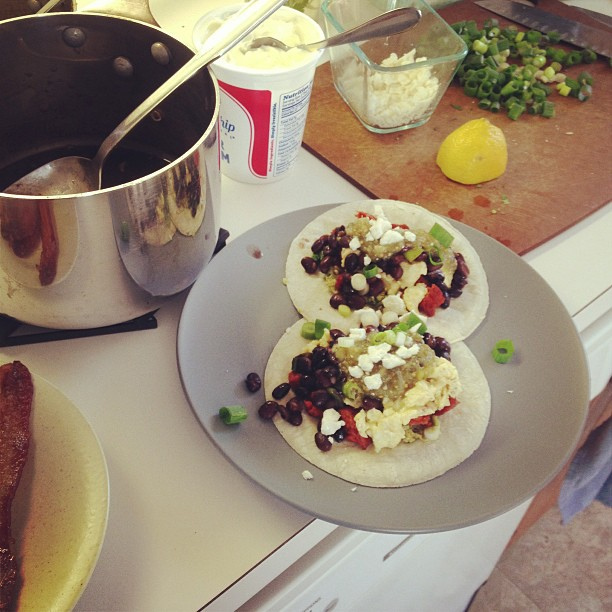<image>What are the small blue items? There are no blue items in the image. The small items could be beans, blue cheese, napkins, or tacos. What are the small blue items? I don't know what are the small blue items. It can be beans, blue cheese, or tacos. 